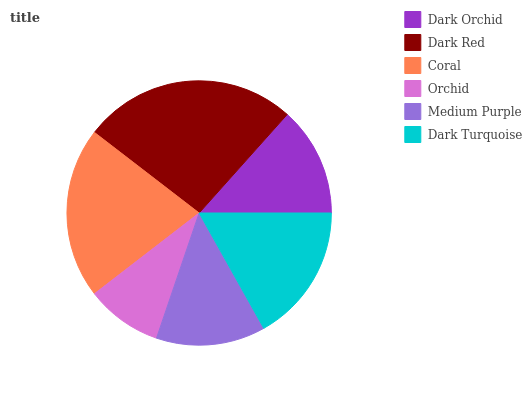Is Orchid the minimum?
Answer yes or no. Yes. Is Dark Red the maximum?
Answer yes or no. Yes. Is Coral the minimum?
Answer yes or no. No. Is Coral the maximum?
Answer yes or no. No. Is Dark Red greater than Coral?
Answer yes or no. Yes. Is Coral less than Dark Red?
Answer yes or no. Yes. Is Coral greater than Dark Red?
Answer yes or no. No. Is Dark Red less than Coral?
Answer yes or no. No. Is Dark Turquoise the high median?
Answer yes or no. Yes. Is Dark Orchid the low median?
Answer yes or no. Yes. Is Dark Orchid the high median?
Answer yes or no. No. Is Orchid the low median?
Answer yes or no. No. 